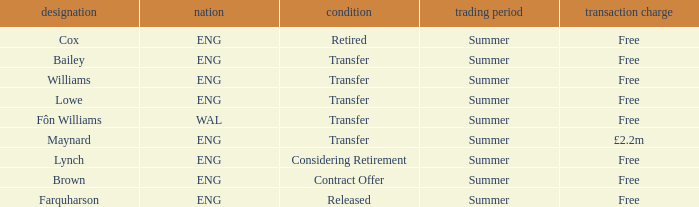What is the name of the free transfer fee with a transfer status and an ENG country? Bailey, Williams, Lowe. 